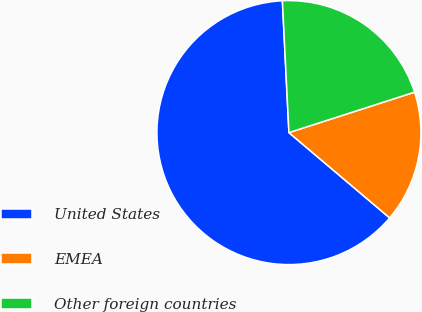Convert chart to OTSL. <chart><loc_0><loc_0><loc_500><loc_500><pie_chart><fcel>United States<fcel>EMEA<fcel>Other foreign countries<nl><fcel>63.03%<fcel>16.14%<fcel>20.83%<nl></chart> 